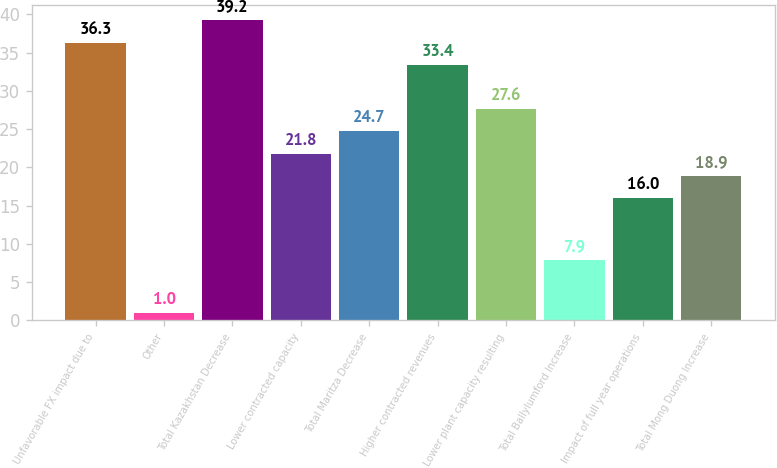Convert chart. <chart><loc_0><loc_0><loc_500><loc_500><bar_chart><fcel>Unfavorable FX impact due to<fcel>Other<fcel>Total Kazakhstan Decrease<fcel>Lower contracted capacity<fcel>Total Maritza Decrease<fcel>Higher contracted revenues<fcel>Lower plant capacity resulting<fcel>Total Ballylumford Increase<fcel>Impact of full year operations<fcel>Total Mong Duong Increase<nl><fcel>36.3<fcel>1<fcel>39.2<fcel>21.8<fcel>24.7<fcel>33.4<fcel>27.6<fcel>7.9<fcel>16<fcel>18.9<nl></chart> 